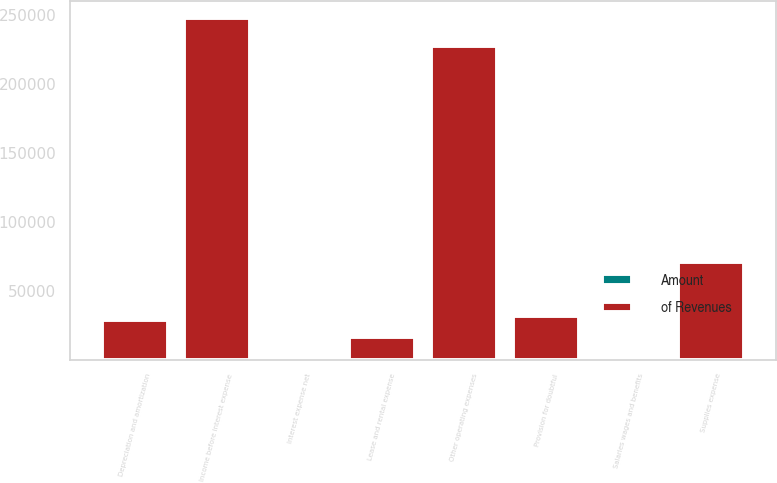Convert chart to OTSL. <chart><loc_0><loc_0><loc_500><loc_500><stacked_bar_chart><ecel><fcel>Salaries wages and benefits<fcel>Other operating expenses<fcel>Supplies expense<fcel>Provision for doubtful<fcel>Depreciation and amortization<fcel>Lease and rental expense<fcel>Income before interest expense<fcel>Interest expense net<nl><fcel>of Revenues<fcel>49.2<fcel>227113<fcel>70926<fcel>32014<fcel>28610<fcel>16218<fcel>247840<fcel>277<nl><fcel>Amount<fcel>49.2<fcel>18.5<fcel>5.8<fcel>2.6<fcel>2.3<fcel>1.3<fcel>20.2<fcel>0<nl></chart> 